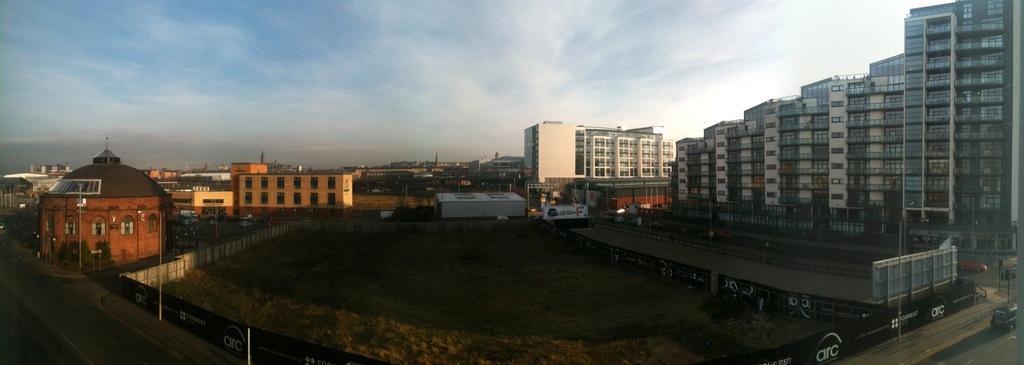In one or two sentences, can you explain what this image depicts? In this picture I can see buildings, trees and poles. On the right side I can see vehicles on the road. In the background I can see sky. 